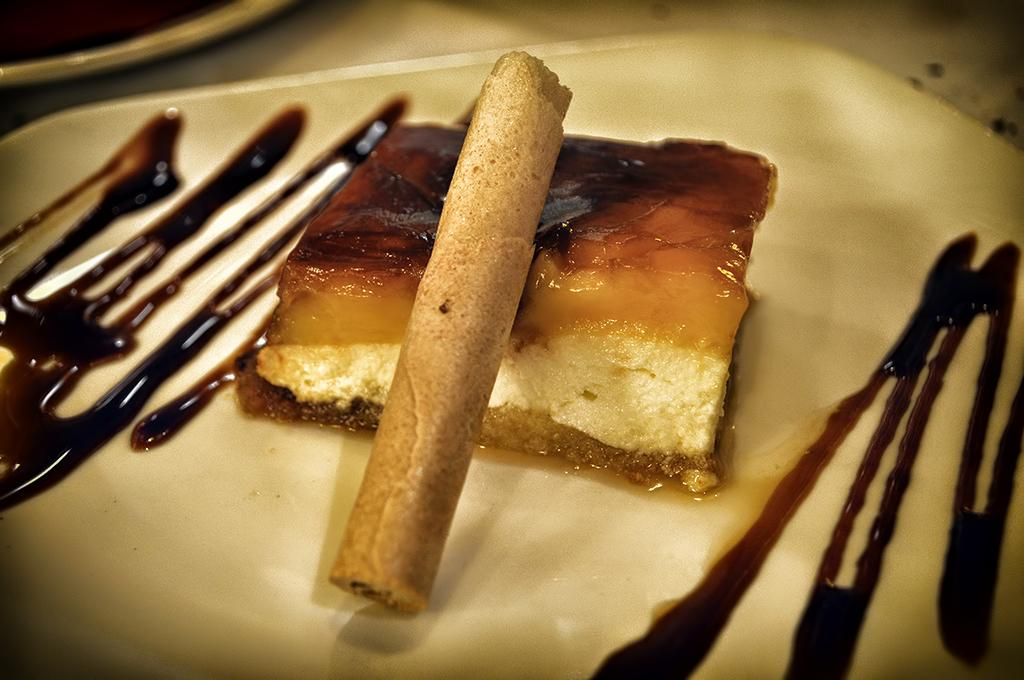What is the main subject of the image? The main subject of the image is food. What can be observed about the plate the food is on? The plate is white in color. What colors are present in the food? The food has brown, yellow, and cream colors. What type of tools does the carpenter use in the image? There is no carpenter present in the image, so no tools can be observed. Can you tell me about the partner of the person in the image? There is no person or partner present in the image, only food on a white plate. 